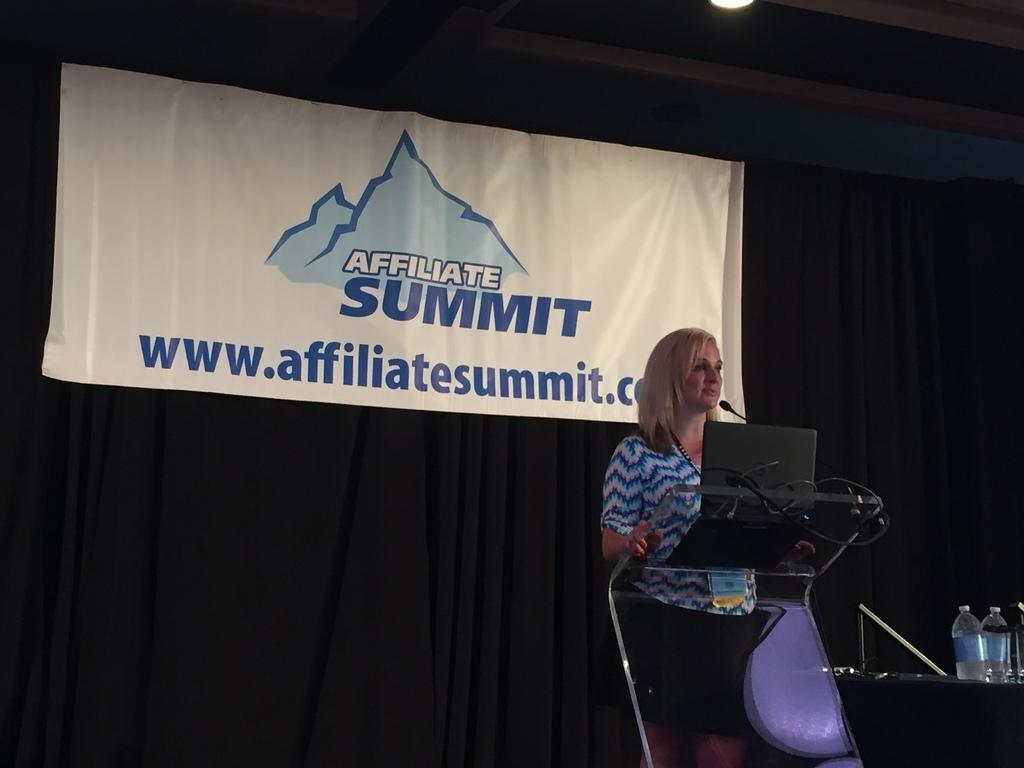<image>
Relay a brief, clear account of the picture shown. A woman at a podium is speaking at the Affiliate Summit. 